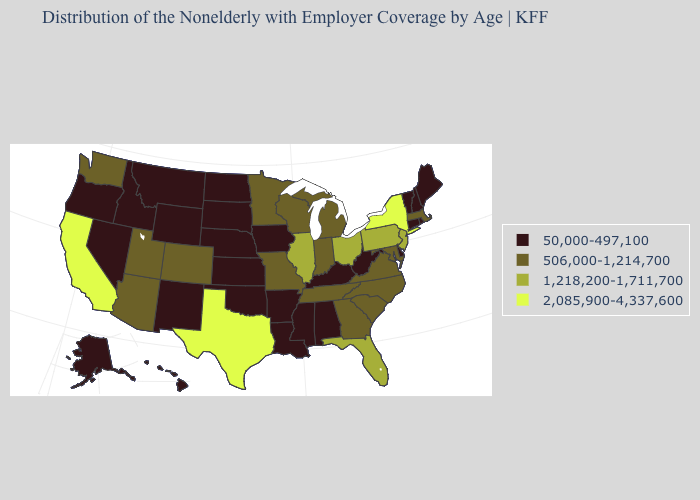What is the value of New Hampshire?
Be succinct. 50,000-497,100. Among the states that border Delaware , which have the highest value?
Give a very brief answer. New Jersey, Pennsylvania. What is the value of South Dakota?
Give a very brief answer. 50,000-497,100. Does Illinois have the lowest value in the MidWest?
Concise answer only. No. Among the states that border Oklahoma , does Texas have the highest value?
Give a very brief answer. Yes. What is the value of Maryland?
Answer briefly. 506,000-1,214,700. Does the map have missing data?
Write a very short answer. No. Name the states that have a value in the range 2,085,900-4,337,600?
Keep it brief. California, New York, Texas. What is the highest value in states that border Iowa?
Short answer required. 1,218,200-1,711,700. Does New Jersey have the highest value in the USA?
Be succinct. No. Name the states that have a value in the range 506,000-1,214,700?
Be succinct. Arizona, Colorado, Georgia, Indiana, Maryland, Massachusetts, Michigan, Minnesota, Missouri, North Carolina, South Carolina, Tennessee, Utah, Virginia, Washington, Wisconsin. What is the value of Utah?
Be succinct. 506,000-1,214,700. What is the value of Utah?
Concise answer only. 506,000-1,214,700. Which states have the lowest value in the USA?
Keep it brief. Alabama, Alaska, Arkansas, Connecticut, Delaware, Hawaii, Idaho, Iowa, Kansas, Kentucky, Louisiana, Maine, Mississippi, Montana, Nebraska, Nevada, New Hampshire, New Mexico, North Dakota, Oklahoma, Oregon, Rhode Island, South Dakota, Vermont, West Virginia, Wyoming. Is the legend a continuous bar?
Concise answer only. No. 